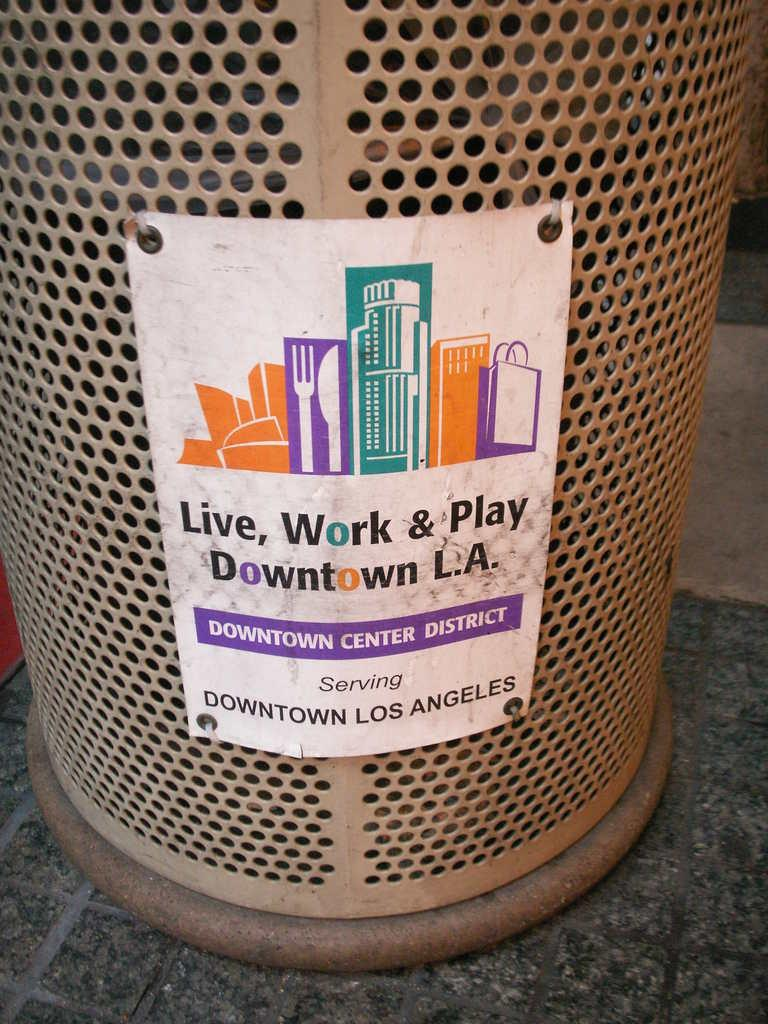<image>
Relay a brief, clear account of the picture shown. A flyer about downtown Los Angeles is on a trash can. 